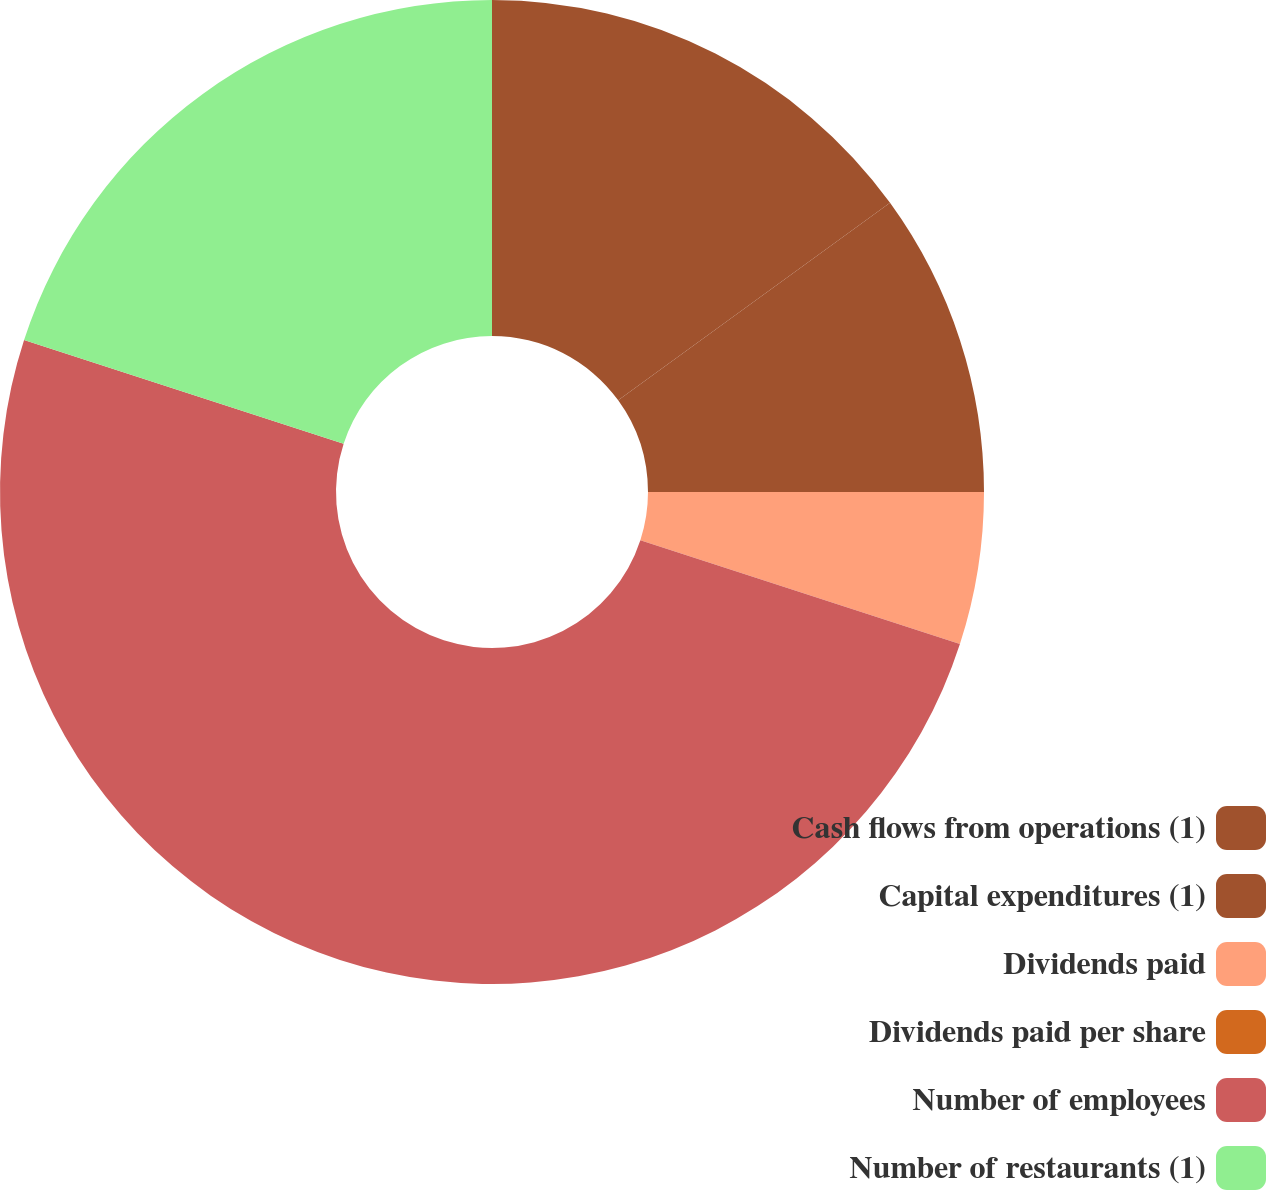Convert chart. <chart><loc_0><loc_0><loc_500><loc_500><pie_chart><fcel>Cash flows from operations (1)<fcel>Capital expenditures (1)<fcel>Dividends paid<fcel>Dividends paid per share<fcel>Number of employees<fcel>Number of restaurants (1)<nl><fcel>15.0%<fcel>10.0%<fcel>5.0%<fcel>0.0%<fcel>50.0%<fcel>20.0%<nl></chart> 